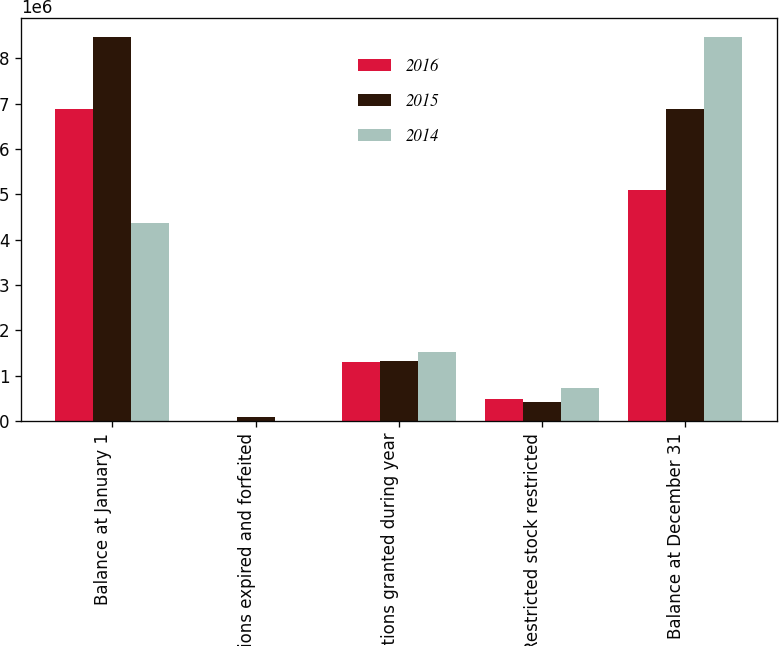Convert chart. <chart><loc_0><loc_0><loc_500><loc_500><stacked_bar_chart><ecel><fcel>Balance at January 1<fcel>Options expired and forfeited<fcel>Options granted during year<fcel>Restricted stock restricted<fcel>Balance at December 31<nl><fcel>2016<fcel>6.87228e+06<fcel>8518<fcel>1.30631e+06<fcel>486033<fcel>5.08846e+06<nl><fcel>2015<fcel>8.45859e+06<fcel>90371<fcel>1.33451e+06<fcel>431913<fcel>6.87228e+06<nl><fcel>2014<fcel>4.36875e+06<fcel>3488<fcel>1.52398e+06<fcel>721286<fcel>8.45859e+06<nl></chart> 